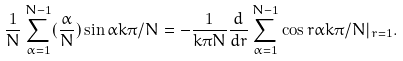Convert formula to latex. <formula><loc_0><loc_0><loc_500><loc_500>\frac { 1 } { N } \sum _ { \alpha = 1 } ^ { N - 1 } ( \frac { \alpha } { N } ) \sin \alpha k \pi / N = - \frac { 1 } { k \pi N } \frac { d } { d r } \sum _ { \alpha = 1 } ^ { N - 1 } \cos r \alpha k \pi / N | _ { r = 1 } .</formula> 